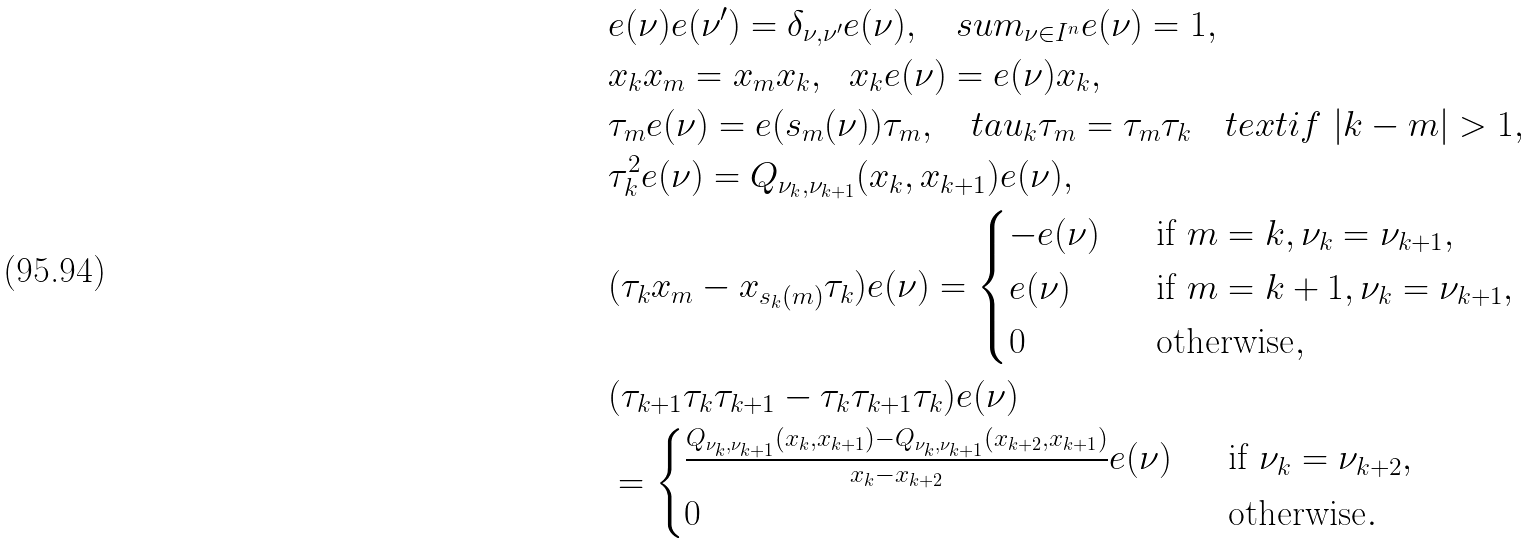<formula> <loc_0><loc_0><loc_500><loc_500>& e ( \nu ) e ( \nu ^ { \prime } ) = \delta _ { \nu , \nu ^ { \prime } } e ( \nu ) , \quad s u m _ { \nu \in I ^ { n } } e ( \nu ) = 1 , \\ & x _ { k } x _ { m } = x _ { m } x _ { k } , \ \ x _ { k } e ( \nu ) = e ( \nu ) x _ { k } , \\ & \tau _ { m } e ( \nu ) = e ( s _ { m } ( \nu ) ) \tau _ { m } , \quad t a u _ { k } \tau _ { m } = \tau _ { m } \tau _ { k } \quad t e x t { i f } \ | k - m | > 1 , \\ & \tau _ { k } ^ { 2 } e ( \nu ) = Q _ { \nu _ { k } , \nu _ { k + 1 } } ( x _ { k } , x _ { k + 1 } ) e ( \nu ) , \\ & ( \tau _ { k } x _ { m } - x _ { s _ { k } ( m ) } \tau _ { k } ) e ( \nu ) = \begin{cases} - e ( \nu ) \ \ & \text {if} \ m = k , \nu _ { k } = \nu _ { k + 1 } , \\ e ( \nu ) \ \ & \text {if} \ m = k + 1 , \nu _ { k } = \nu _ { k + 1 } , \\ 0 \ \ & \text {otherwise} , \end{cases} \\ & ( \tau _ { k + 1 } \tau _ { k } \tau _ { k + 1 } - \tau _ { k } \tau _ { k + 1 } \tau _ { k } ) e ( \nu ) \\ & = \begin{cases} \frac { Q _ { \nu _ { k } , \nu _ { k + 1 } } ( x _ { k } , x _ { k + 1 } ) - Q _ { \nu _ { k } , \nu _ { k + 1 } } ( x _ { k + 2 } , x _ { k + 1 } ) } { x _ { k } - x _ { k + 2 } } e ( \nu ) \ \ & \text {if} \ \nu _ { k } = \nu _ { k + 2 } , \\ 0 \ \ & \text {otherwise} . \end{cases}</formula> 